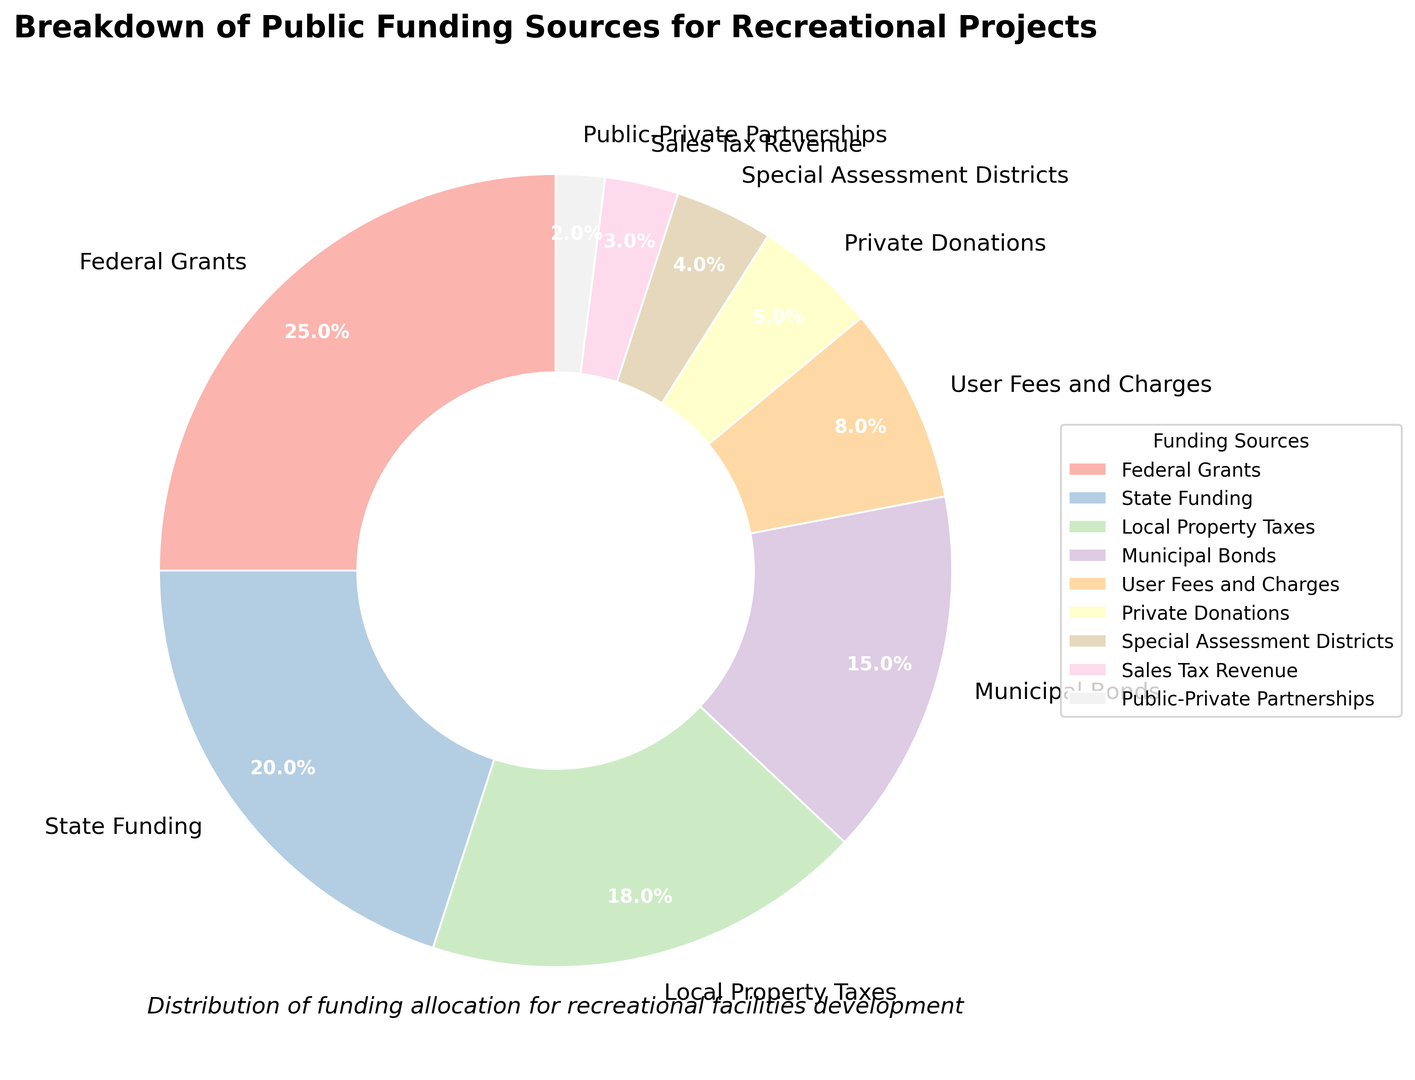what percentage of the total funding comes from Federal Grants? The Federal Grants section of the pie chart is labeled with its respective percentage, which is shown as 25%.
Answer: 25% Which funding source contributes less, Public-Private Partnerships or Private Donations? Looking at the pie chart, Public-Private Partnerships account for 2% of the total funding, while Private Donations account for 5%. Since 2% is less than 5%, Public-Private Partnerships contribute less.
Answer: Public-Private Partnerships What are the combined percentages of Local Property Taxes and Municipal Bonds? Local Property Taxes contribute 18% and Municipal Bonds contribute 15%. Adding these together yields: 18% + 15% = 33%.
Answer: 33% Which category has the second highest percentage of funding, and what is that percentage? Federal Grants is the highest at 25%. The second highest is State Funding, which is labeled with 20%.
Answer: State Funding, 20% Compare the total percentage of all sources contributing less than 5% to the total percentage of Local Property Taxes. The sources contributing less than 5% are Public-Private Partnerships (2%), Sales Tax Revenue (3%), and Special Assessment Districts (4%). Adding these, we get: 2% + 3% + 4% = 9%. Local Property Taxes contribute 18%. Therefore, the total percentage of these smaller sources (9%) is less than that of Local Property Taxes (18%).
Answer: Less Which colors represent the State Funding and User Fees and Charges segments in the pie chart? Visual inspection of the pie chart will show the specific colors associated with each segment. The colors are assigned uniquely to each funding source. (Assume the chart adheres strictly to the Pastel1 colormap, but specific color names or hex values should be avoided as per requirements.)
Answer: Describe the visual colors observed in the chart, e.g., light blue for State Funding and pale yellow for User Fees and Charges If you combine the percentages for Local Property Taxes and Private Donations, how does this sum compare to State Funding? Local Property Taxes contribute 18% and Private Donations contribute 5%. Their combined percentage is: 18% + 5% = 23%. State Funding contributes 20%, so the combined percentage (23%) is greater than State Funding (20%).
Answer: Greater How many categories have percentages that are 10% or higher? The categories with percentages 10% or higher are Federal Grants (25%), State Funding (20%), Local Property Taxes (18%), and Municipal Bonds (15%). Counting these, we get a total of 4 categories.
Answer: 4 